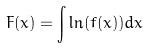Convert formula to latex. <formula><loc_0><loc_0><loc_500><loc_500>F ( x ) = \int \ln ( f ( x ) ) d x</formula> 